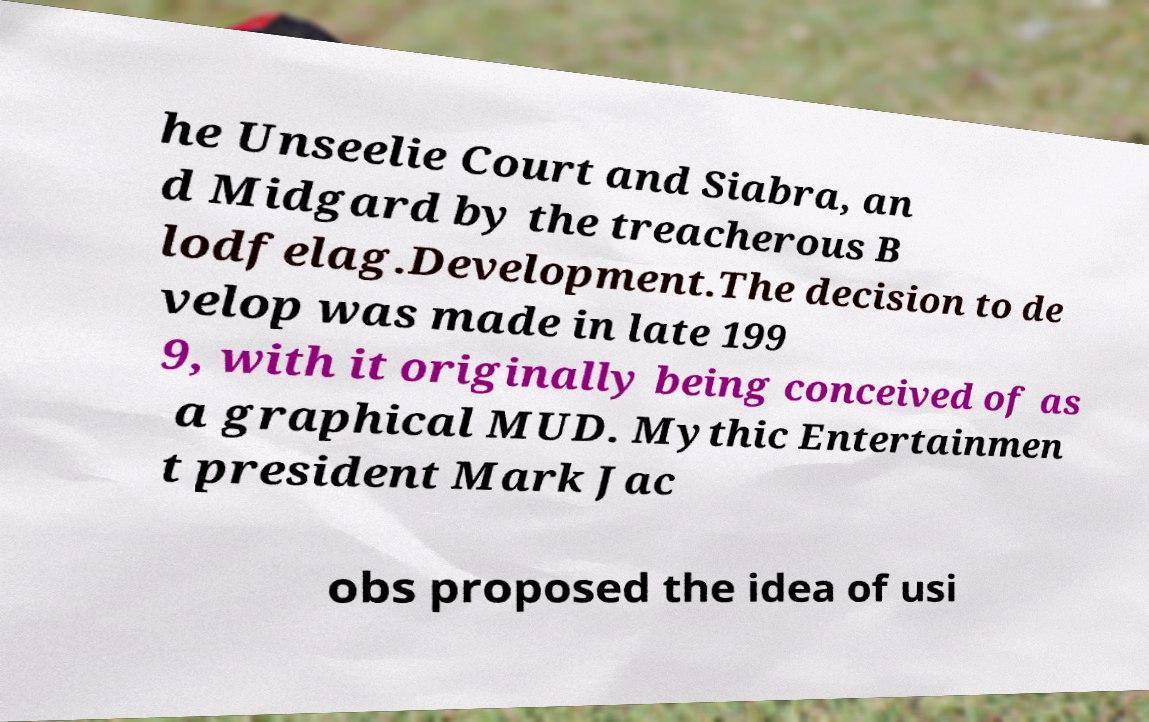Please read and relay the text visible in this image. What does it say? he Unseelie Court and Siabra, an d Midgard by the treacherous B lodfelag.Development.The decision to de velop was made in late 199 9, with it originally being conceived of as a graphical MUD. Mythic Entertainmen t president Mark Jac obs proposed the idea of usi 